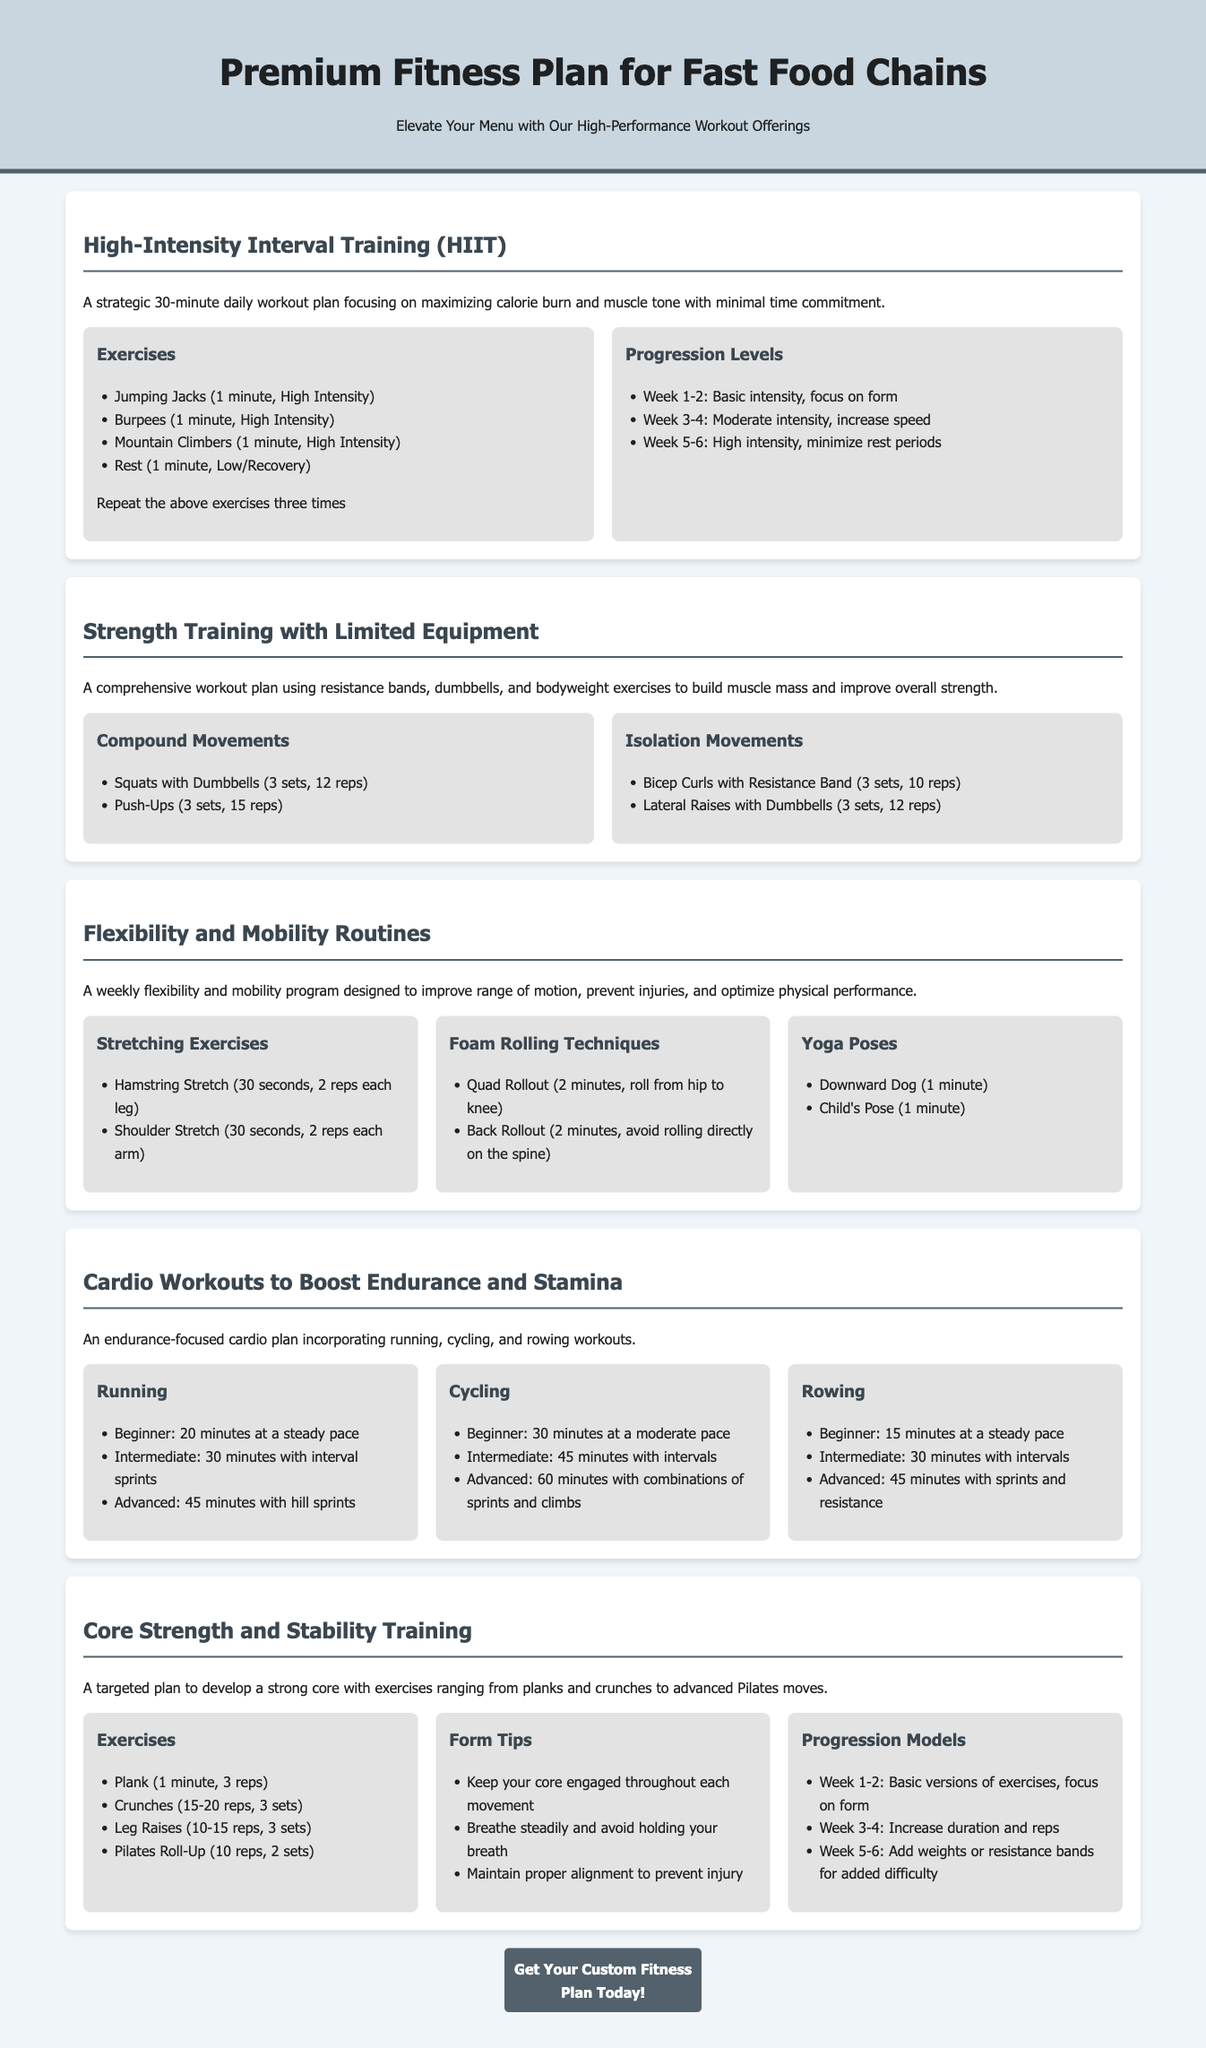what is the duration of the HIIT workout plan? The HIIT workout plan is a 30-minute daily workout plan.
Answer: 30 minutes how many times should the HIIT exercises be repeated? The HIIT exercises should be repeated three times.
Answer: three times what is one of the compound movements listed in Strength Training? One of the compound movements listed is Squats with Dumbbells.
Answer: Squats with Dumbbells how long should the Downward Dog yoga pose be held? The Downward Dog yoga pose should be held for 1 minute.
Answer: 1 minute what are the levels of progression for HIIT training? The levels of progression are Week 1-2, Week 3-4, and Week 5-6.
Answer: Week 1-2, Week 3-4, Week 5-6 which exercise is recommended for core strength in the training schedule? Plank is recommended for core strength.
Answer: Plank what is the recommended duration for beginner cycling workouts? The recommended duration for beginner cycling workouts is 30 minutes.
Answer: 30 minutes how many sets of Bicep Curls with Resistance Band are recommended? Three sets of Bicep Curls with Resistance Band are recommended.
Answer: three sets what type of training is emphasized in the document? The document emphasizes fitness training for busy professionals.
Answer: fitness training for busy professionals 